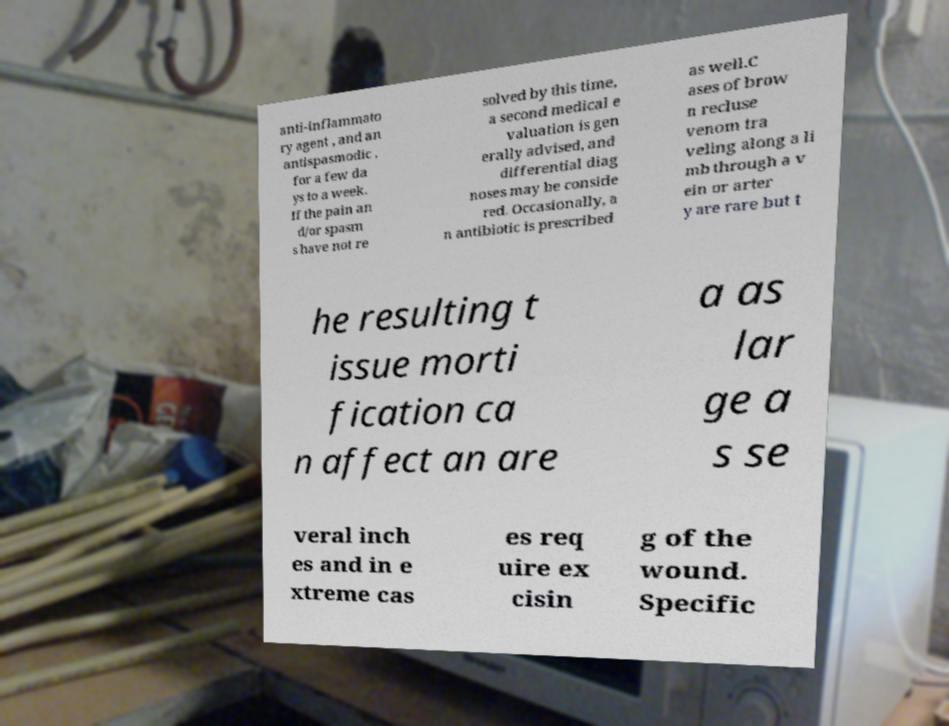Could you extract and type out the text from this image? anti-inflammato ry agent , and an antispasmodic , for a few da ys to a week. If the pain an d/or spasm s have not re solved by this time, a second medical e valuation is gen erally advised, and differential diag noses may be conside red. Occasionally, a n antibiotic is prescribed as well.C ases of brow n recluse venom tra veling along a li mb through a v ein or arter y are rare but t he resulting t issue morti fication ca n affect an are a as lar ge a s se veral inch es and in e xtreme cas es req uire ex cisin g of the wound. Specific 